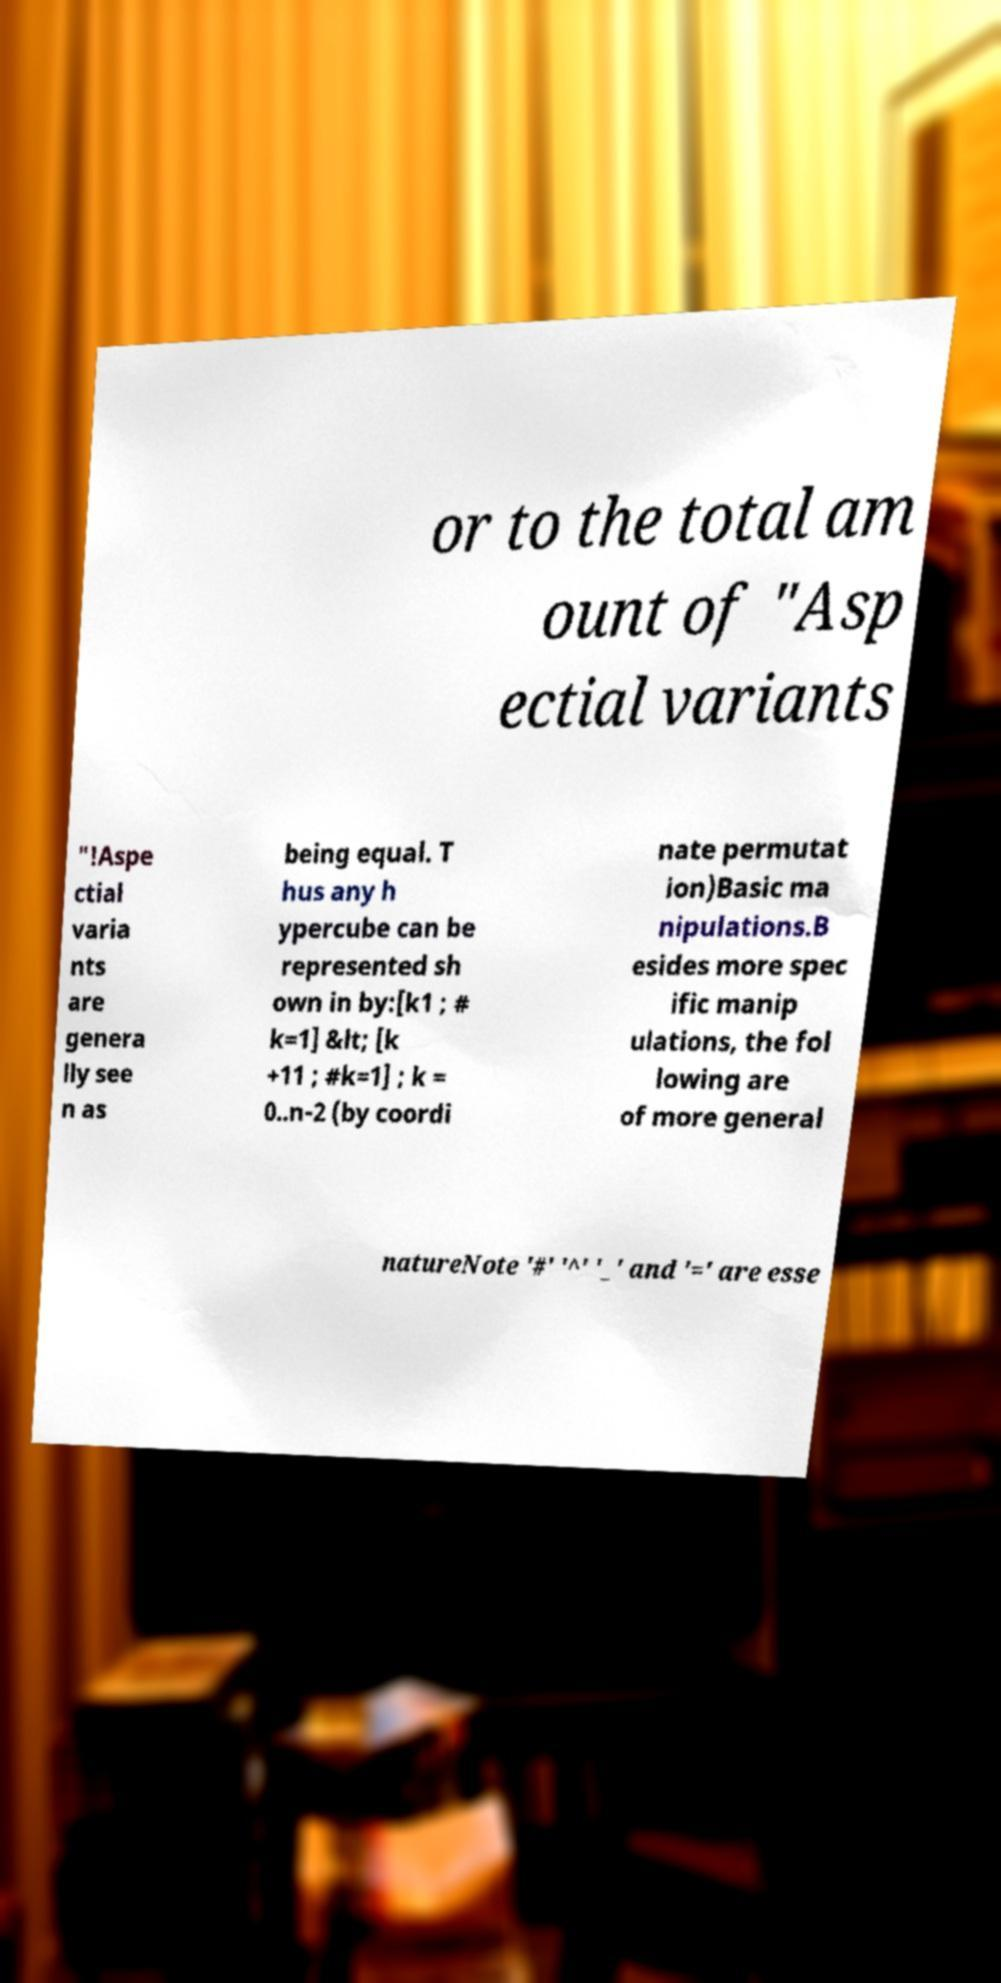Can you accurately transcribe the text from the provided image for me? or to the total am ount of "Asp ectial variants "!Aspe ctial varia nts are genera lly see n as being equal. T hus any h ypercube can be represented sh own in by:[k1 ; # k=1] &lt; [k +11 ; #k=1] ; k = 0..n-2 (by coordi nate permutat ion)Basic ma nipulations.B esides more spec ific manip ulations, the fol lowing are of more general natureNote '#' '^' '_' and '=' are esse 